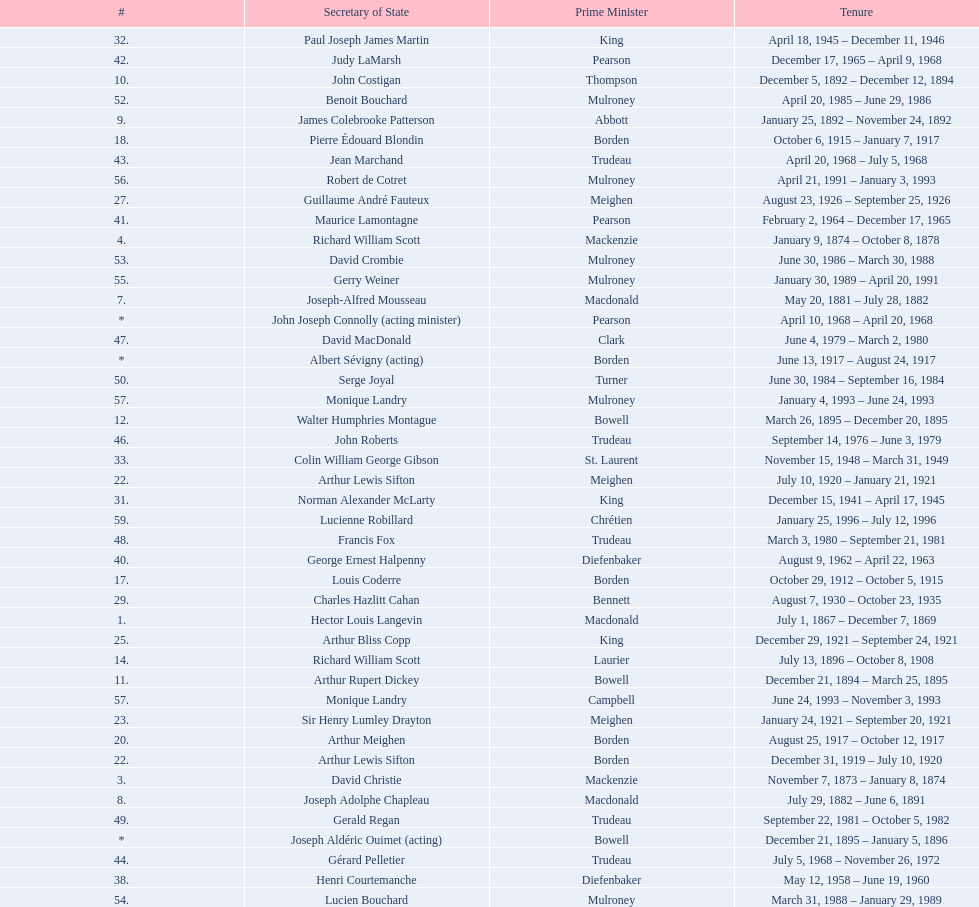Was macdonald prime minister before or after bowell? Before. 